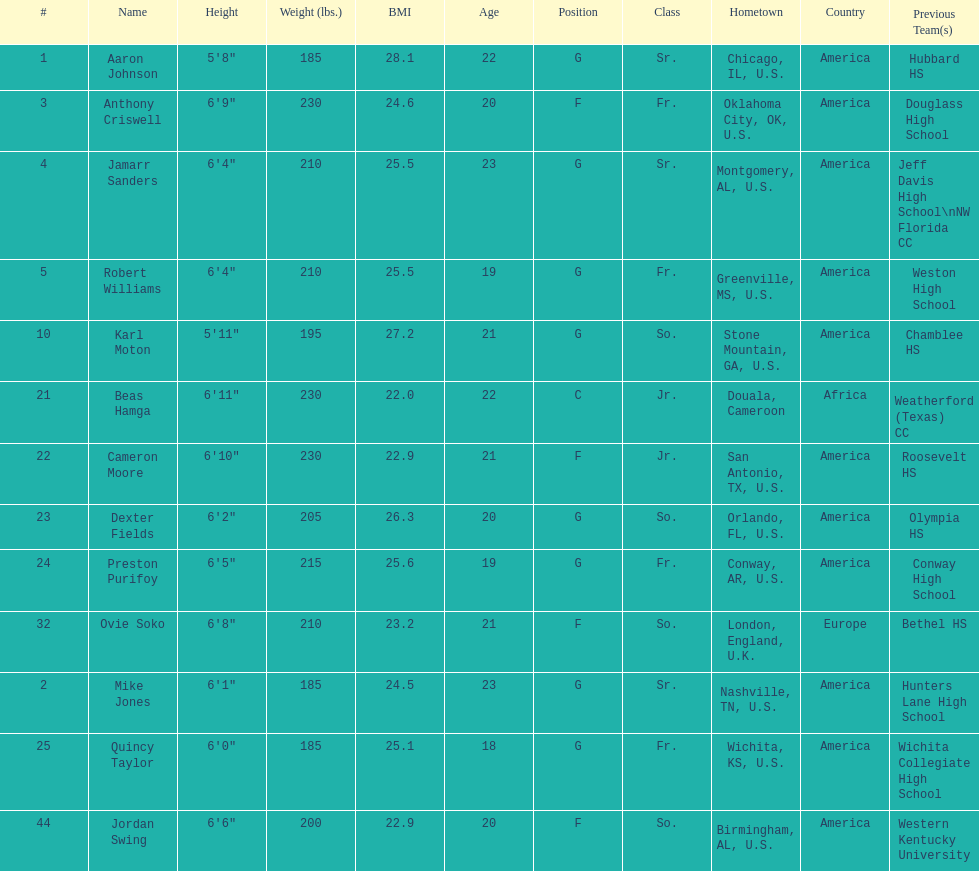What is the average weight of jamarr sanders and robert williams? 210. 